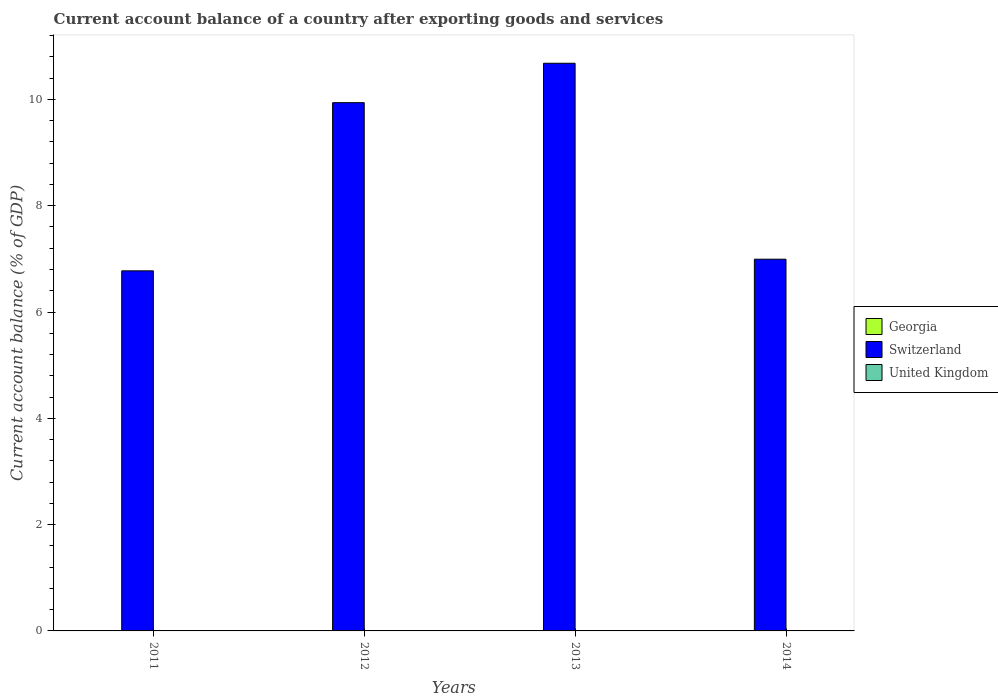Are the number of bars per tick equal to the number of legend labels?
Keep it short and to the point. No. Are the number of bars on each tick of the X-axis equal?
Offer a terse response. Yes. How many bars are there on the 4th tick from the right?
Your answer should be compact. 1. In how many cases, is the number of bars for a given year not equal to the number of legend labels?
Your answer should be compact. 4. What is the account balance in United Kingdom in 2013?
Your response must be concise. 0. Across all years, what is the maximum account balance in Switzerland?
Keep it short and to the point. 10.68. Across all years, what is the minimum account balance in Switzerland?
Offer a terse response. 6.77. What is the total account balance in United Kingdom in the graph?
Offer a very short reply. 0. What is the difference between the account balance in United Kingdom in 2011 and the account balance in Switzerland in 2012?
Your response must be concise. -9.94. What is the average account balance in United Kingdom per year?
Your answer should be very brief. 0. What is the ratio of the account balance in Switzerland in 2012 to that in 2014?
Your answer should be compact. 1.42. Is the account balance in Switzerland in 2012 less than that in 2014?
Your answer should be compact. No. What is the difference between the highest and the second highest account balance in Switzerland?
Ensure brevity in your answer.  0.74. What is the difference between the highest and the lowest account balance in Switzerland?
Make the answer very short. 3.91. Are all the bars in the graph horizontal?
Your answer should be very brief. No. What is the difference between two consecutive major ticks on the Y-axis?
Offer a very short reply. 2. Where does the legend appear in the graph?
Give a very brief answer. Center right. How are the legend labels stacked?
Make the answer very short. Vertical. What is the title of the graph?
Provide a short and direct response. Current account balance of a country after exporting goods and services. Does "Serbia" appear as one of the legend labels in the graph?
Provide a succinct answer. No. What is the label or title of the X-axis?
Offer a very short reply. Years. What is the label or title of the Y-axis?
Give a very brief answer. Current account balance (% of GDP). What is the Current account balance (% of GDP) in Switzerland in 2011?
Keep it short and to the point. 6.77. What is the Current account balance (% of GDP) of United Kingdom in 2011?
Keep it short and to the point. 0. What is the Current account balance (% of GDP) in Switzerland in 2012?
Provide a short and direct response. 9.94. What is the Current account balance (% of GDP) of Switzerland in 2013?
Your answer should be very brief. 10.68. What is the Current account balance (% of GDP) of United Kingdom in 2013?
Ensure brevity in your answer.  0. What is the Current account balance (% of GDP) in Georgia in 2014?
Provide a short and direct response. 0. What is the Current account balance (% of GDP) in Switzerland in 2014?
Provide a succinct answer. 6.99. Across all years, what is the maximum Current account balance (% of GDP) in Switzerland?
Provide a short and direct response. 10.68. Across all years, what is the minimum Current account balance (% of GDP) of Switzerland?
Give a very brief answer. 6.77. What is the total Current account balance (% of GDP) of Georgia in the graph?
Your response must be concise. 0. What is the total Current account balance (% of GDP) in Switzerland in the graph?
Make the answer very short. 34.39. What is the total Current account balance (% of GDP) of United Kingdom in the graph?
Your answer should be compact. 0. What is the difference between the Current account balance (% of GDP) in Switzerland in 2011 and that in 2012?
Ensure brevity in your answer.  -3.16. What is the difference between the Current account balance (% of GDP) of Switzerland in 2011 and that in 2013?
Offer a terse response. -3.91. What is the difference between the Current account balance (% of GDP) of Switzerland in 2011 and that in 2014?
Your response must be concise. -0.22. What is the difference between the Current account balance (% of GDP) of Switzerland in 2012 and that in 2013?
Ensure brevity in your answer.  -0.74. What is the difference between the Current account balance (% of GDP) in Switzerland in 2012 and that in 2014?
Provide a succinct answer. 2.95. What is the difference between the Current account balance (% of GDP) of Switzerland in 2013 and that in 2014?
Ensure brevity in your answer.  3.69. What is the average Current account balance (% of GDP) of Georgia per year?
Offer a very short reply. 0. What is the average Current account balance (% of GDP) of Switzerland per year?
Your answer should be compact. 8.6. What is the ratio of the Current account balance (% of GDP) of Switzerland in 2011 to that in 2012?
Give a very brief answer. 0.68. What is the ratio of the Current account balance (% of GDP) of Switzerland in 2011 to that in 2013?
Provide a succinct answer. 0.63. What is the ratio of the Current account balance (% of GDP) in Switzerland in 2011 to that in 2014?
Give a very brief answer. 0.97. What is the ratio of the Current account balance (% of GDP) in Switzerland in 2012 to that in 2013?
Ensure brevity in your answer.  0.93. What is the ratio of the Current account balance (% of GDP) of Switzerland in 2012 to that in 2014?
Make the answer very short. 1.42. What is the ratio of the Current account balance (% of GDP) in Switzerland in 2013 to that in 2014?
Your answer should be compact. 1.53. What is the difference between the highest and the second highest Current account balance (% of GDP) in Switzerland?
Offer a very short reply. 0.74. What is the difference between the highest and the lowest Current account balance (% of GDP) of Switzerland?
Provide a succinct answer. 3.91. 